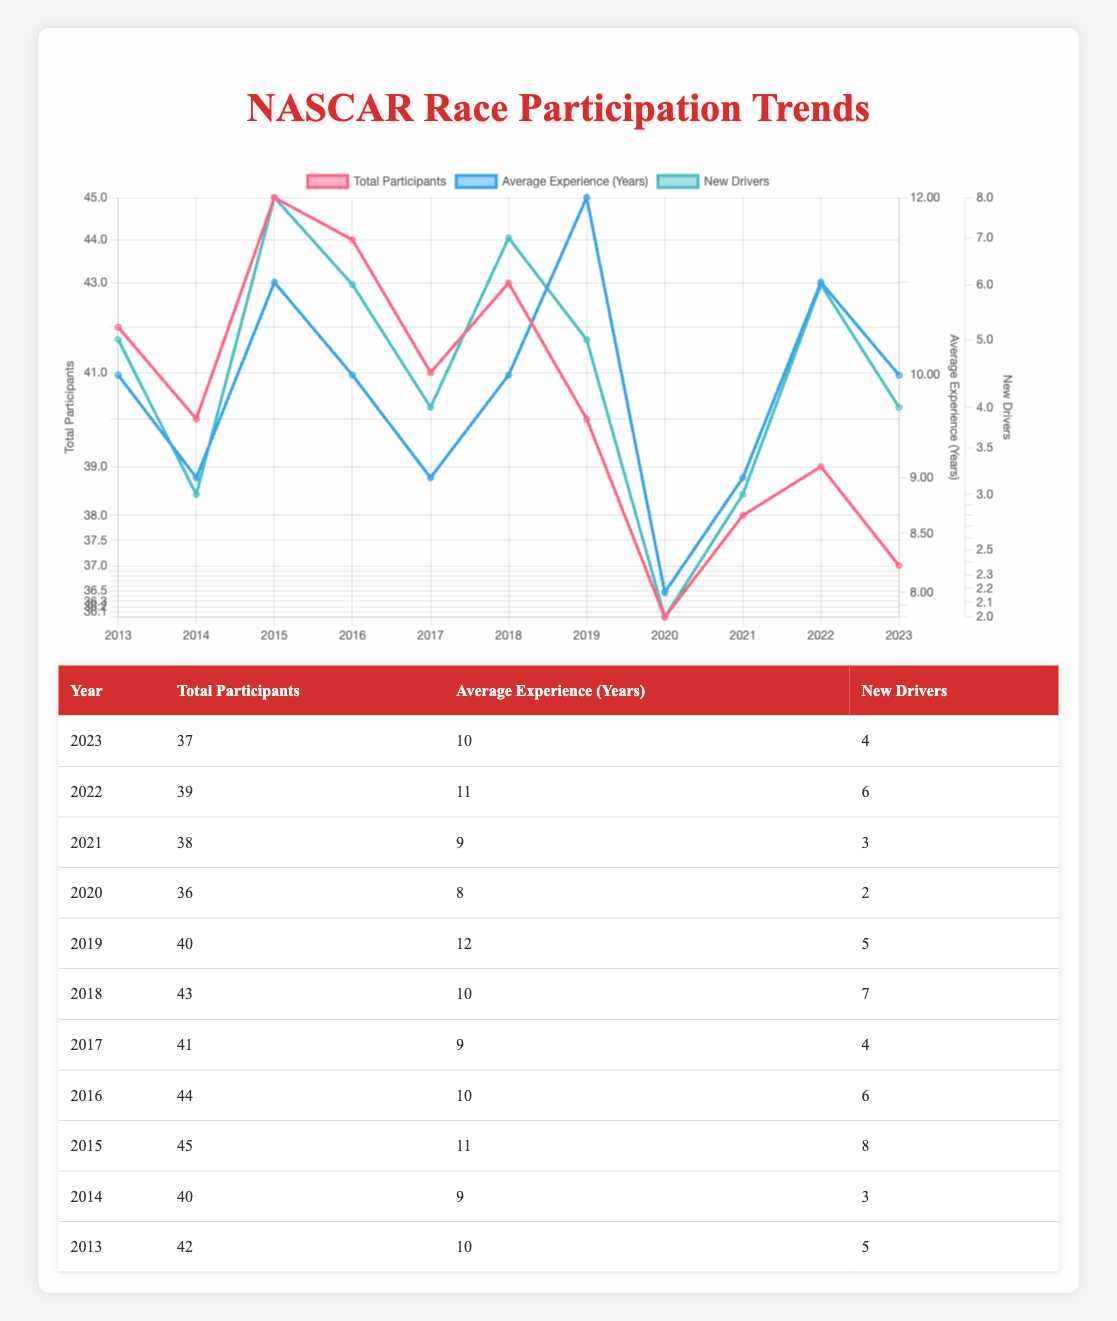What was the total number of participants in 2015? In the table, I can see the row for the year 2015 shows 'Total Participants' as 45.
Answer: 45 How many new drivers participated in 2020? Looking at the row for the year 2020 in the table, 'New Drivers' is listed as 2.
Answer: 2 What is the average experience of drivers in 2019? Referring to the 2019 row, the 'Average Experience (Years)' is shown as 12.
Answer: 12 In which year did the total number of participants reach its lowest point, and what was that number? Scanning the year column and corresponding total participants, I see that 2020 has the least value, which is 36.
Answer: 2020, 36 How many more new drivers participated in 2015 compared to 2021? For 2015, there were 8 new drivers, and for 2021, there were 3 new drivers. So, calculating the difference: 8 - 3 = 5.
Answer: 5 Was the average experience of drivers higher in 2022 than in 2016? In the 2022 row, the average experience is listed as 11 years, while in 2016, it is shown as 10 years. Since 11 is greater than 10, the answer is yes.
Answer: Yes What is the total of new drivers from 2013 to 2018? To find this, I add the new drivers from each of these years: 5 (2013) + 3 (2014) + 8 (2015) + 6 (2016) + 4 (2017) + 7 (2018) = 33.
Answer: 33 During which years was the average experience of drivers 10 years? The years with an average experience of 10 years are 2013, 2016, and 2018. I can find these years in the rows of the table.
Answer: 2013, 2016, 2018 Did the average number of participants increase from 2014 to 2015? The total participants in 2014 was 40, and in 2015, it was 45. Since 45 is greater than 40, it did increase.
Answer: Yes 